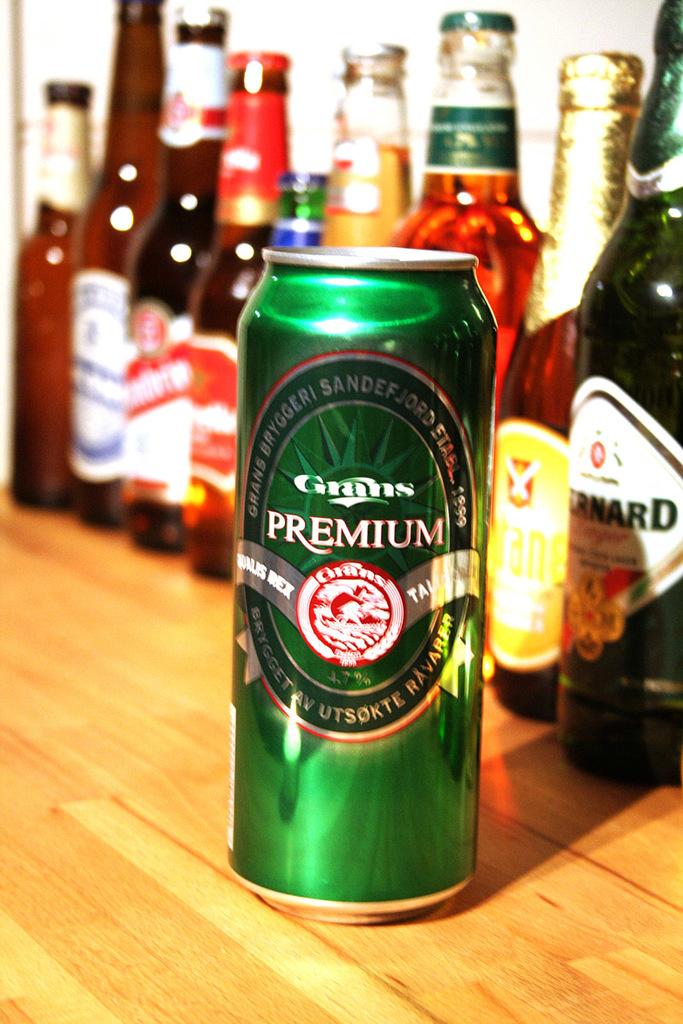What is the name of the beer in the green can?
Your response must be concise. Grans premium. 